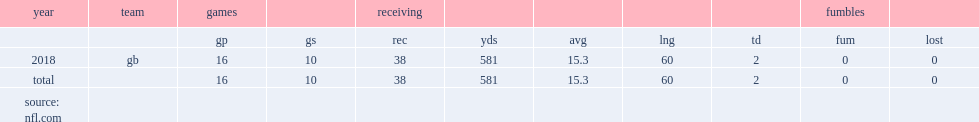Write the full table. {'header': ['year', 'team', 'games', '', 'receiving', '', '', '', '', 'fumbles', ''], 'rows': [['', '', 'gp', 'gs', 'rec', 'yds', 'avg', 'lng', 'td', 'fum', 'lost'], ['2018', 'gb', '16', '10', '38', '581', '15.3', '60', '2', '0', '0'], ['total', '', '16', '10', '38', '581', '15.3', '60', '2', '0', '0'], ['source: nfl.com', '', '', '', '', '', '', '', '', '', '']]} How many receptions did marquez valdes-scantling get in 2018? 38.0. 